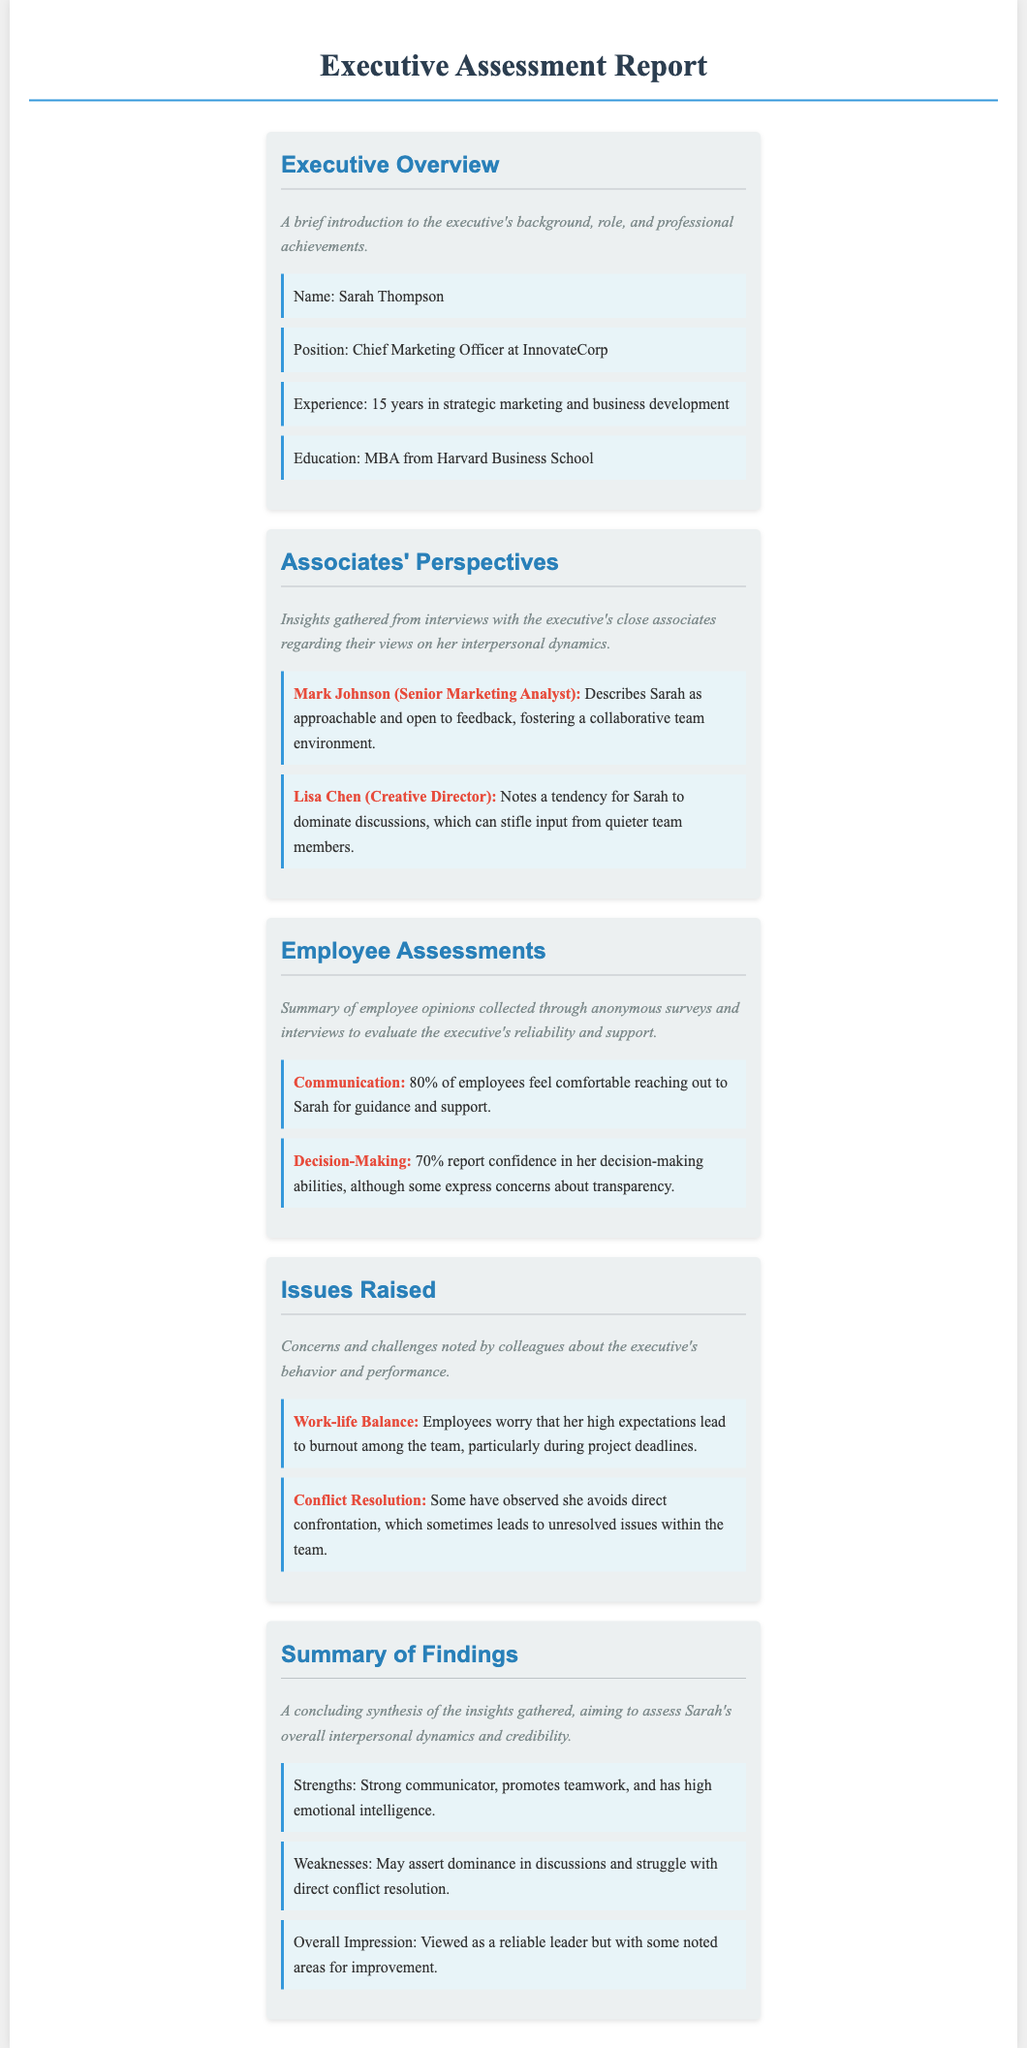What is the executive's name? The executive's name is listed under the Executive Overview section.
Answer: Sarah Thompson What position does Sarah Thompson hold? Sarah's position is mentioned in the Executive Overview section.
Answer: Chief Marketing Officer at InnovateCorp How many years of experience does Sarah have? Her years of experience are detailed in the Executive Overview section.
Answer: 15 years What percentage of employees feel comfortable reaching out to Sarah? This percentage is found in the Employee Assessments section.
Answer: 80% What is one strength noted in the Summary of Findings? Strengths are listed in the Summary of Findings section.
Answer: Strong communicator What issue related to work-life balance was raised? The issue is stated in the Issues Raised section, detailing concerns from employees.
Answer: Employees worry that her high expectations lead to burnout among the team Who reported concerns about Sarah's decision-making transparency? Concerns are mentioned in the Employee Assessments section, indicating employee perceptions.
Answer: Some employees What is Lisa Chen's role? Lisa's role is included under the Associates' Perspectives section.
Answer: Creative Director What overall impression do employees have of Sarah? The overall impression is found in the Summary of Findings section.
Answer: Viewed as a reliable leader but with some noted areas for improvement 